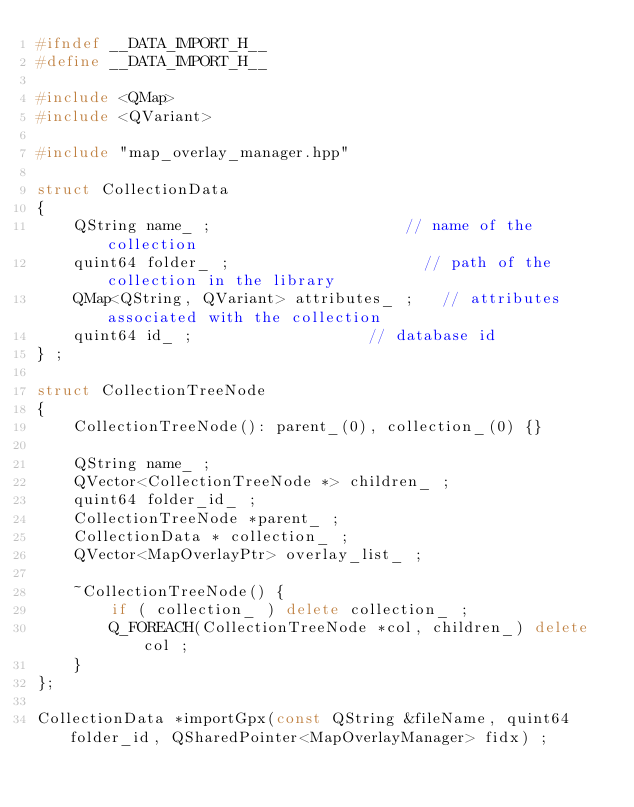Convert code to text. <code><loc_0><loc_0><loc_500><loc_500><_C++_>#ifndef __DATA_IMPORT_H__
#define __DATA_IMPORT_H__

#include <QMap>
#include <QVariant>

#include "map_overlay_manager.hpp"

struct CollectionData
{
    QString name_ ;                     // name of the collection
    quint64 folder_ ;                     // path of the collection in the library
    QMap<QString, QVariant> attributes_ ;   // attributes associated with the collection
    quint64 id_ ;                   // database id
} ;

struct CollectionTreeNode
{
    CollectionTreeNode(): parent_(0), collection_(0) {}

    QString name_ ;
    QVector<CollectionTreeNode *> children_ ;
    quint64 folder_id_ ;
    CollectionTreeNode *parent_ ;
    CollectionData * collection_ ;
    QVector<MapOverlayPtr> overlay_list_ ;

    ~CollectionTreeNode() {
        if ( collection_ ) delete collection_ ;
        Q_FOREACH(CollectionTreeNode *col, children_) delete col ;
    }
};

CollectionData *importGpx(const QString &fileName, quint64 folder_id, QSharedPointer<MapOverlayManager> fidx) ;</code> 